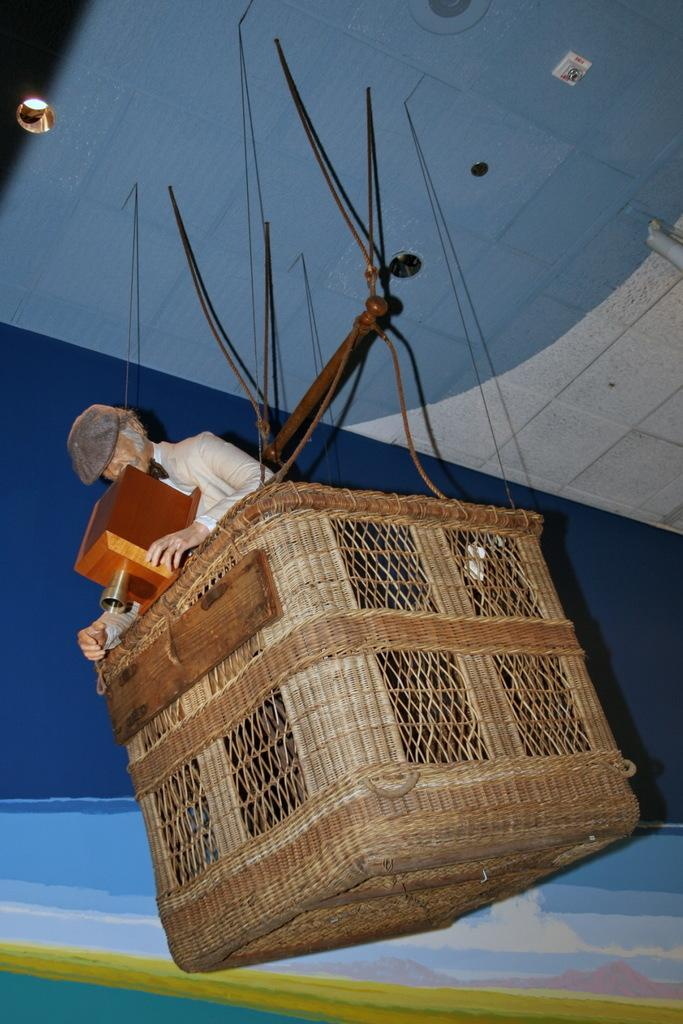What can be seen in the image that serves as a background? There is a wall in the image that serves as a background. What object is present in the image that can hold items? There is a basket in the image that can hold items. Who or what is inside the basket? There is a person in the basket. What is the person wearing on their head? The person is wearing a hat. What is the person wearing on their body? The person is wearing a white dress. What type of angle is the carpenter using to cut the wood in the image? There is no carpenter or wood present in the image. How many balloons are tied to the person's wrist in the image? There are no balloons present in the image. 